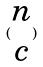Convert formula to latex. <formula><loc_0><loc_0><loc_500><loc_500>( \begin{matrix} n \\ c \end{matrix} )</formula> 